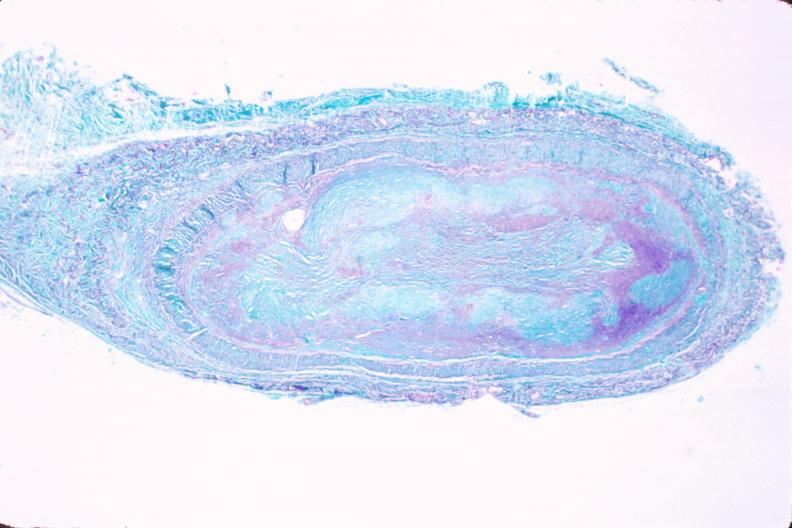what is present?
Answer the question using a single word or phrase. Vasculature 